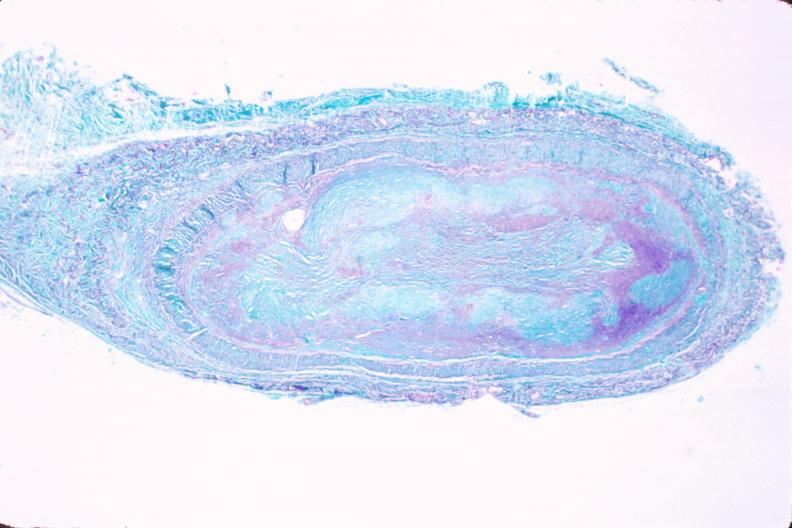what is present?
Answer the question using a single word or phrase. Vasculature 